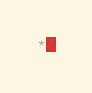<code> <loc_0><loc_0><loc_500><loc_500><_JavaScript_>*/
</code> 